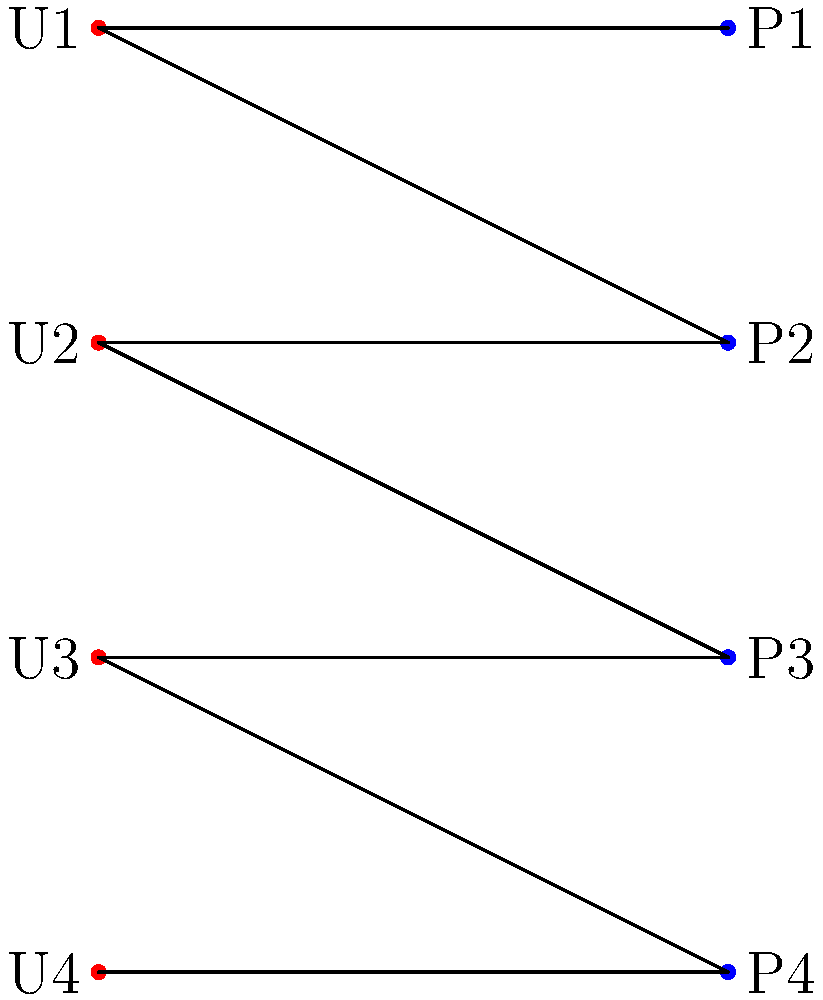In a mobile app security system, user-permission relationships are modeled using a bipartite graph. Users (U) are represented on the left, and permissions (P) on the right. An edge between a user and a permission indicates that the user has that permission. Given the graph above, what is the minimum number of permissions that need to be revoked to ensure no user has more than one permission? To solve this problem, we need to find the minimum number of edges to remove so that each user (U) has at most one edge connecting to a permission (P). This is equivalent to finding the minimum edge cover in the bipartite graph.

Step 1: Analyze the current state of the graph:
- U1 has permissions P1 and P2
- U2 has permissions P2 and P3
- U3 has permissions P3 and P4
- U4 has permission P4

Step 2: Identify the minimum number of edges to remove:
- We need to remove one edge from U1, U2, and U3 to ensure they each have only one permission.
- U4 already has only one permission, so no edge removal is needed for U4.

Step 3: Calculate the total number of edges to remove:
- 1 edge from U1
- 1 edge from U2
- 1 edge from U3
- Total: 3 edges

Therefore, the minimum number of permissions that need to be revoked (edges to be removed) is 3.
Answer: 3 